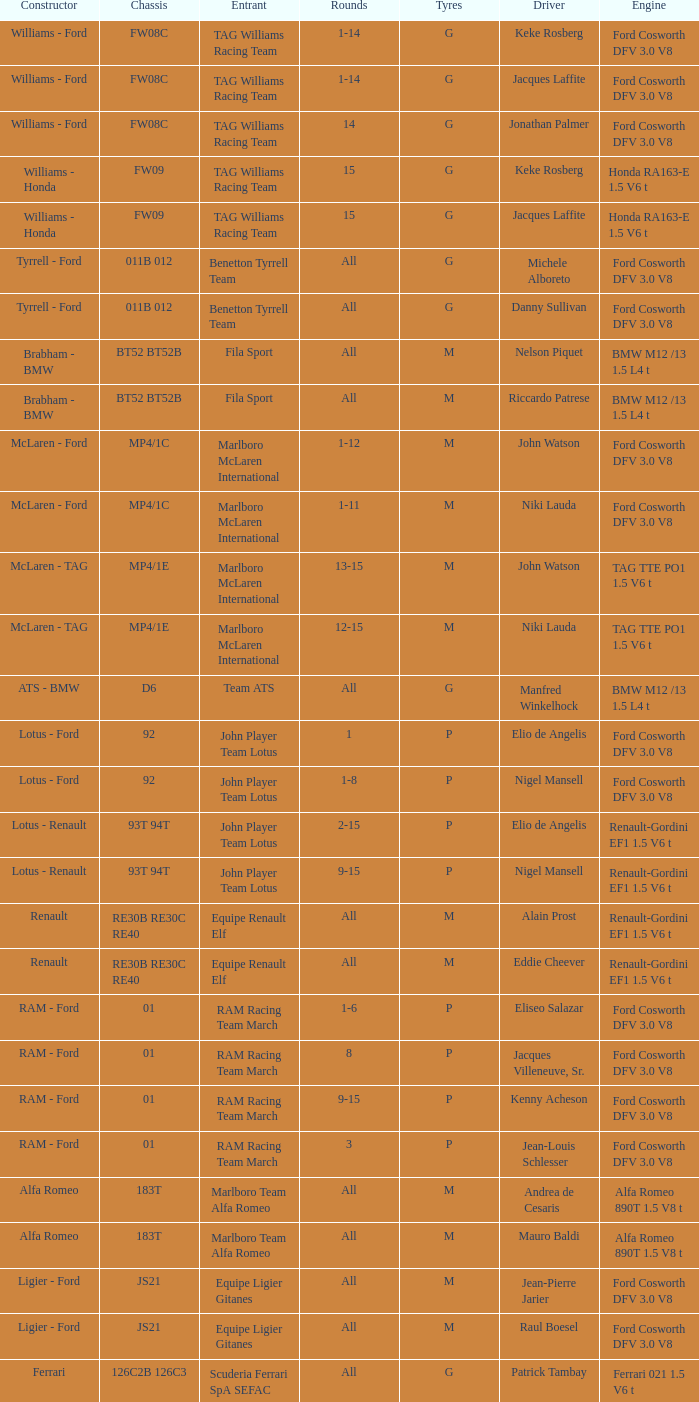Who is the Constructor for driver Piercarlo Ghinzani and a Ford cosworth dfv 3.0 v8 engine? Osella - Ford. 